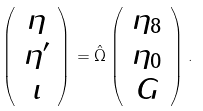<formula> <loc_0><loc_0><loc_500><loc_500>\left ( \begin{array} { c } \eta \\ \eta ^ { \prime } \\ \iota \end{array} \right ) = \hat { \Omega } \left ( \begin{array} { c } \eta _ { 8 } \\ \eta _ { 0 } \\ G \end{array} \right ) .</formula> 